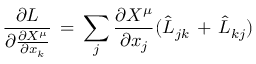Convert formula to latex. <formula><loc_0><loc_0><loc_500><loc_500>\frac { \partial L } { \partial \frac { \partial X ^ { \mu } } { \partial x _ { k } } } \, = \, \sum _ { j } \frac { \partial X ^ { \mu } } { \partial x _ { j } } ( \hat { L } _ { j k } \, + \, \hat { L } _ { k j } )</formula> 